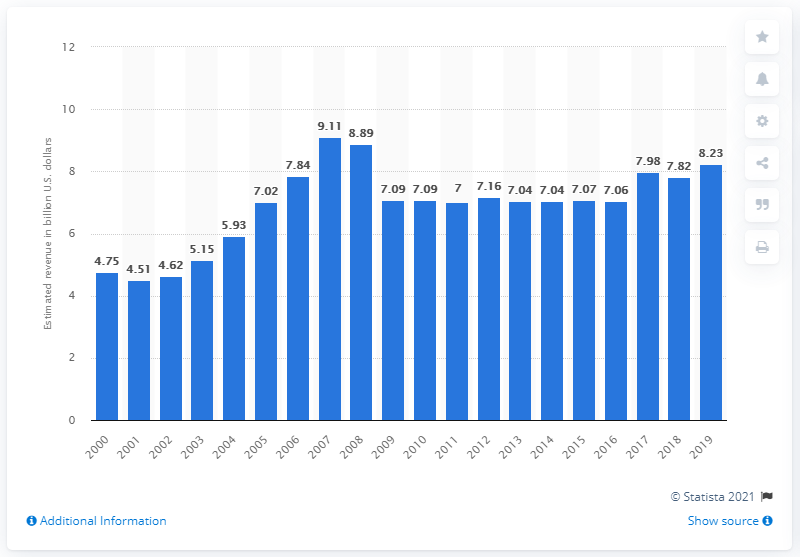Mention a couple of crucial points in this snapshot. In 2019, the total revenue of U.S. outdoor advertising providers was $8.23 billion. 